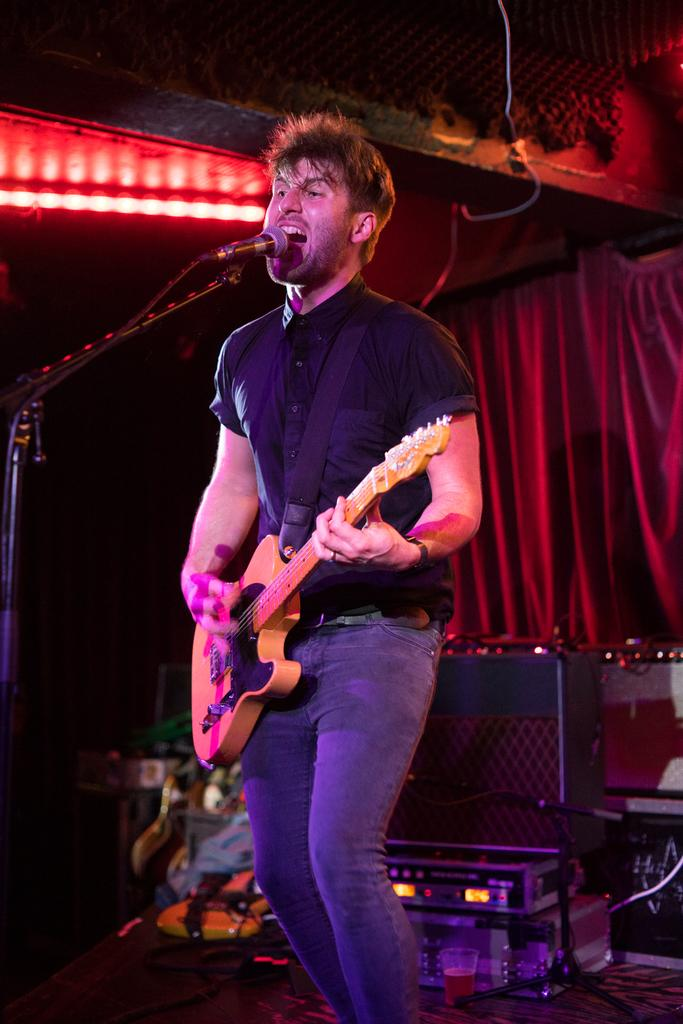What can be seen in the background of the image? There is a red curtain in the background of the image. What can be seen illuminated in the image? There are lights visible in the image. What is the man doing in the image? The man is standing on a platform, playing a guitar, and singing. What is the man using to amplify his voice in the image? The man is in front of a microphone. Can you see a squirrel on the man's shoulder in the image? No, there is no squirrel present in the image. What type of journey is the man embarking on in the image? The image does not depict a journey; it shows a man playing a guitar and singing. 